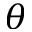<formula> <loc_0><loc_0><loc_500><loc_500>\theta</formula> 